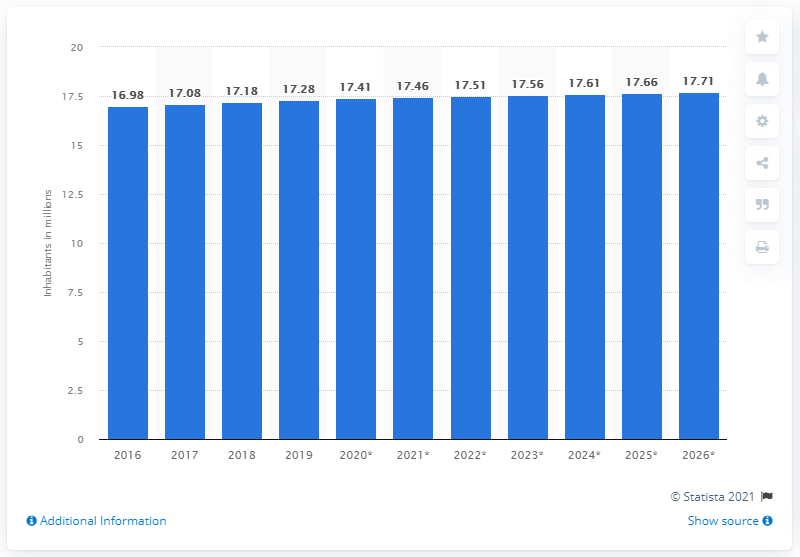Point out several critical features in this image. In 2019, the population of the Netherlands was 17.41 million people. 